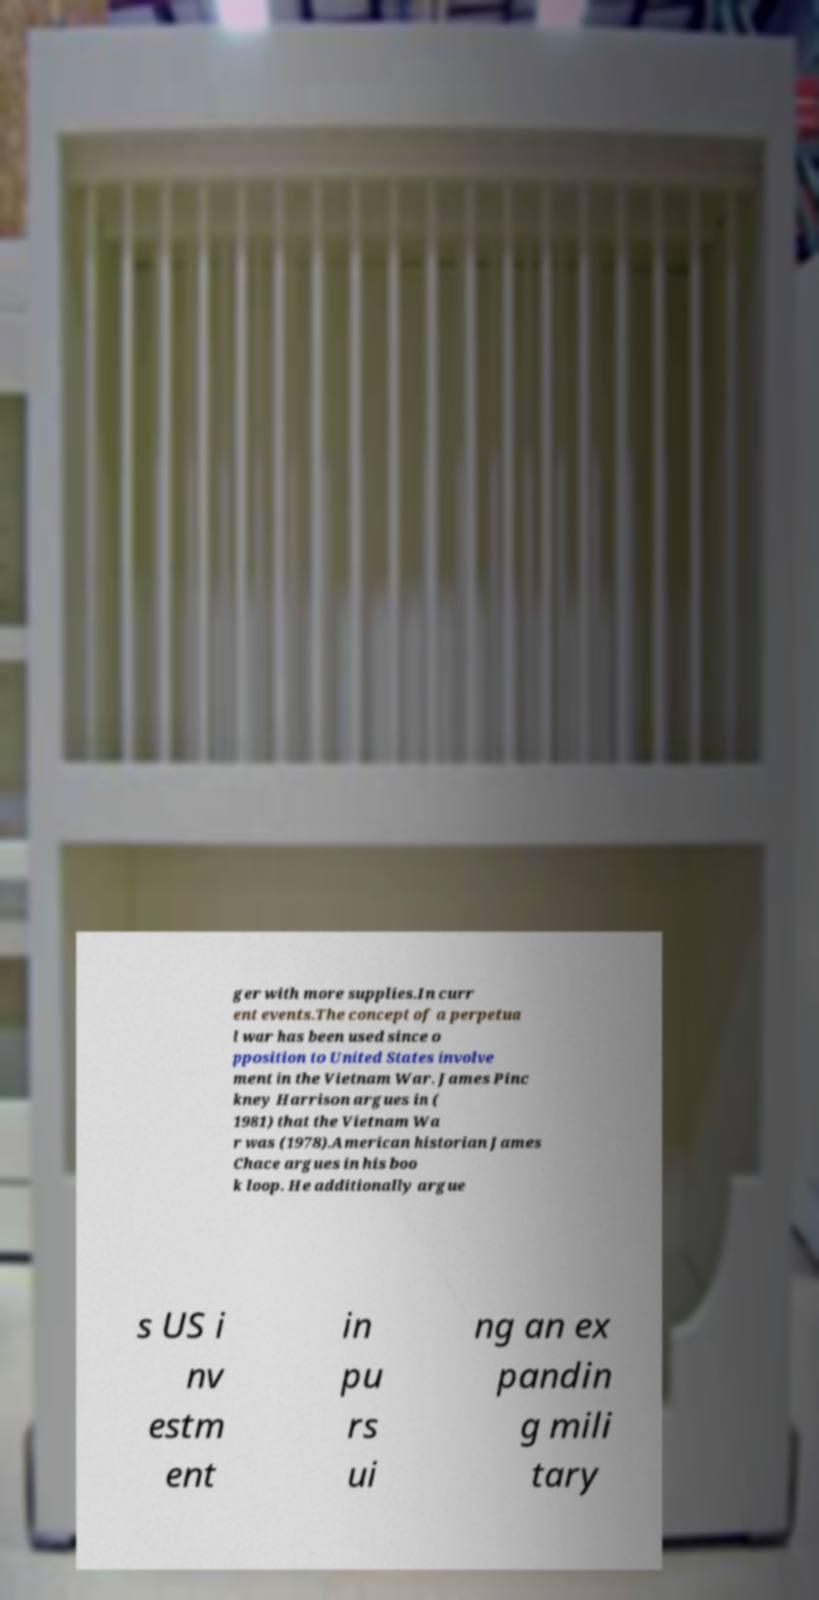Could you extract and type out the text from this image? ger with more supplies.In curr ent events.The concept of a perpetua l war has been used since o pposition to United States involve ment in the Vietnam War. James Pinc kney Harrison argues in ( 1981) that the Vietnam Wa r was (1978).American historian James Chace argues in his boo k loop. He additionally argue s US i nv estm ent in pu rs ui ng an ex pandin g mili tary 